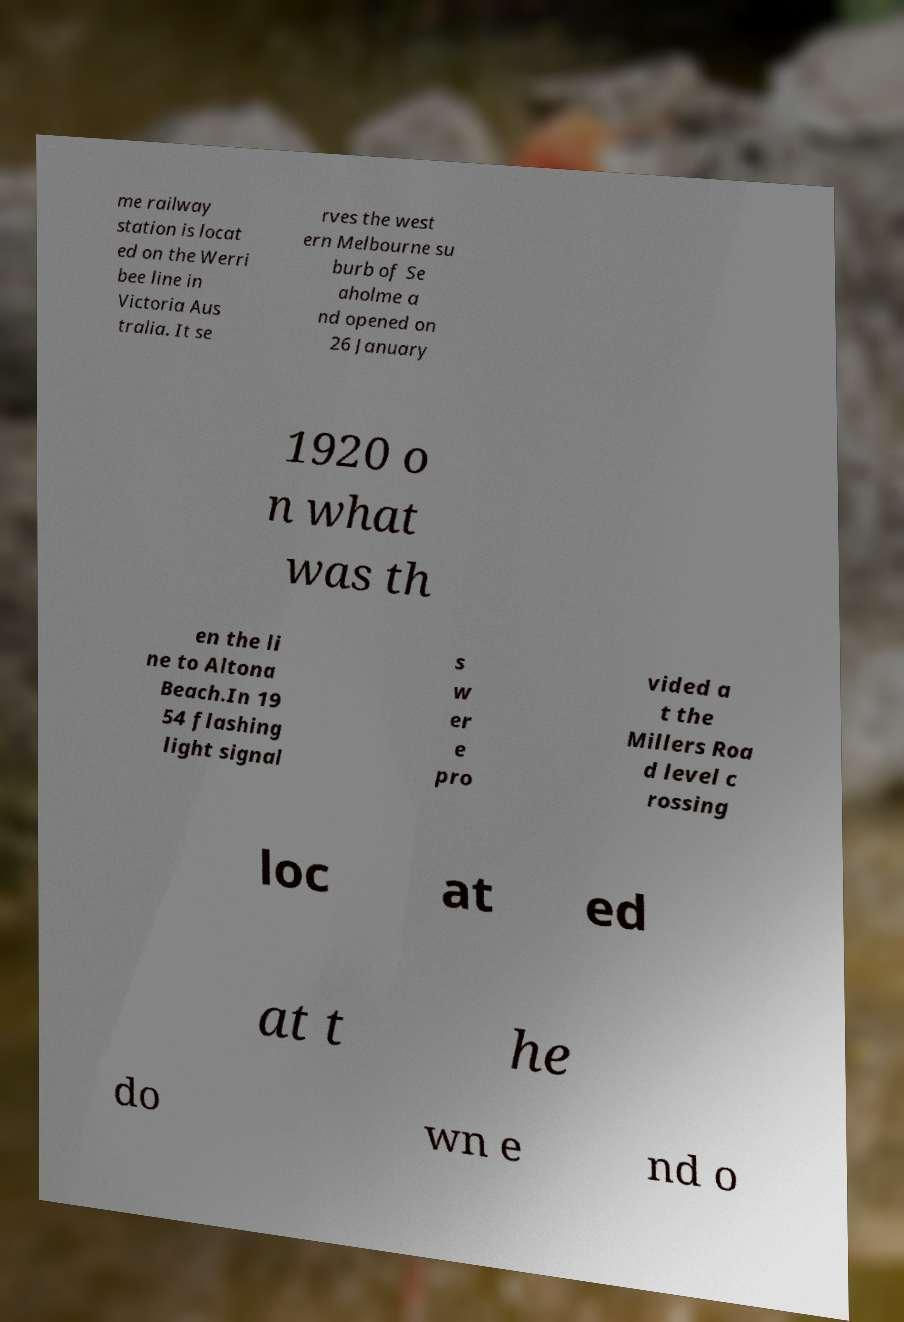Can you accurately transcribe the text from the provided image for me? me railway station is locat ed on the Werri bee line in Victoria Aus tralia. It se rves the west ern Melbourne su burb of Se aholme a nd opened on 26 January 1920 o n what was th en the li ne to Altona Beach.In 19 54 flashing light signal s w er e pro vided a t the Millers Roa d level c rossing loc at ed at t he do wn e nd o 